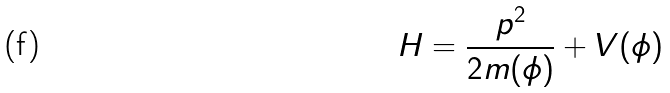<formula> <loc_0><loc_0><loc_500><loc_500>H = \frac { p ^ { 2 } } { 2 m ( \phi ) } + V ( \phi )</formula> 